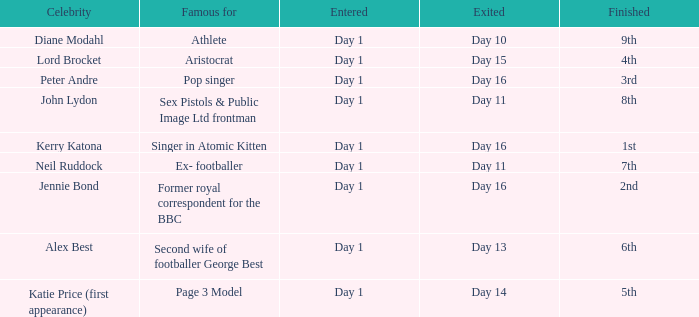Name the number of celebrity for athlete 1.0. 